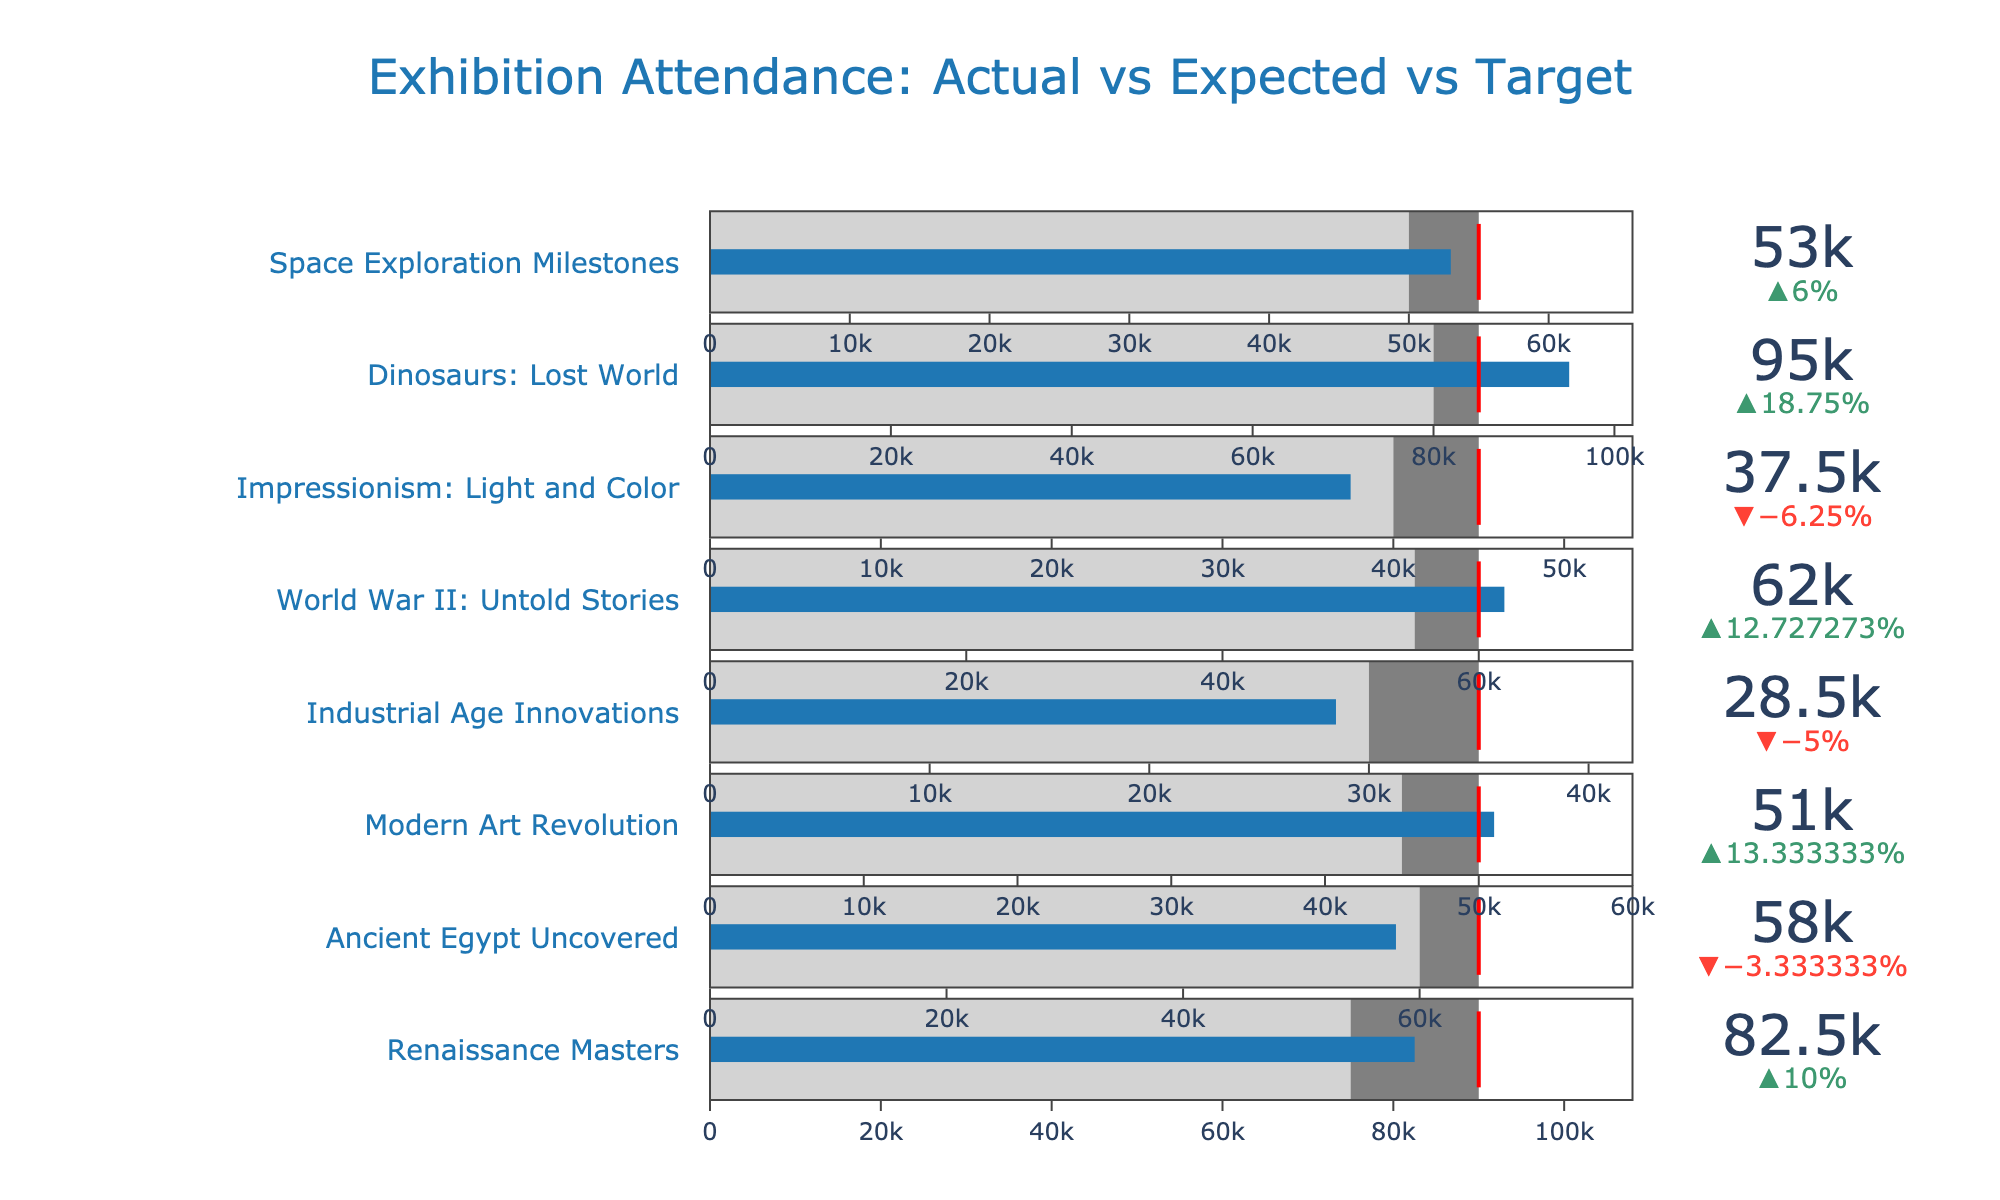What's the title of the chart? The title of the chart is displayed at the top of the figure. It provides a summary of what the chart represents. By looking at the top of the figure, you can see the text that serves as the title.
Answer: "Exhibition Attendance: Actual vs Expected vs Target" Which exhibition had the highest actual attendance? To find the highest actual attendance, scan through the "Actual" values for each exhibition displayed in the chart. Compare these values and identify the highest one.
Answer: "Dinosaurs: Lost World" Did any exhibitions have actual attendance higher than the target? Review the actual attendance values for each exhibition and compare them to their respective target values. Identify any cases where the actual attendance exceeds the target.
Answer: "Renaissance Masters" and "Dinosaurs: Lost World" Which exhibition came closest to meeting its target attendance? Calculate the absolute difference between the actual and target attendance for each exhibition. The smallest difference indicates the closest match.
Answer: "Renaissance Masters" (range within 7500 of the target) Which exhibitions had actual attendance lower than their expected values? Compare the actual attendance values to the expected values for each exhibition. Identify those where the actual attendance is lower.
Answer: "Ancient Egypt Uncovered", "Industrial Age Innovations", "Impressionism: Light and Color" How many exhibitions had actual attendance that was between their expected and target values? Review the actual attendance figures and see how many fall between the expected and target values for each exhibition.
Answer: 4 exhibitions ("Renaissance Masters", "Modern Art Revolution", "World War II: Untold Stories", "Space Exploration Milestones") Which exhibition had the largest positive delta (relative increase from expected to actual)? Calculate the delta (Actual - Expected)/Expected for each exhibition and find the largest positive value.
Answer: "Dinosaurs: Lost World" 